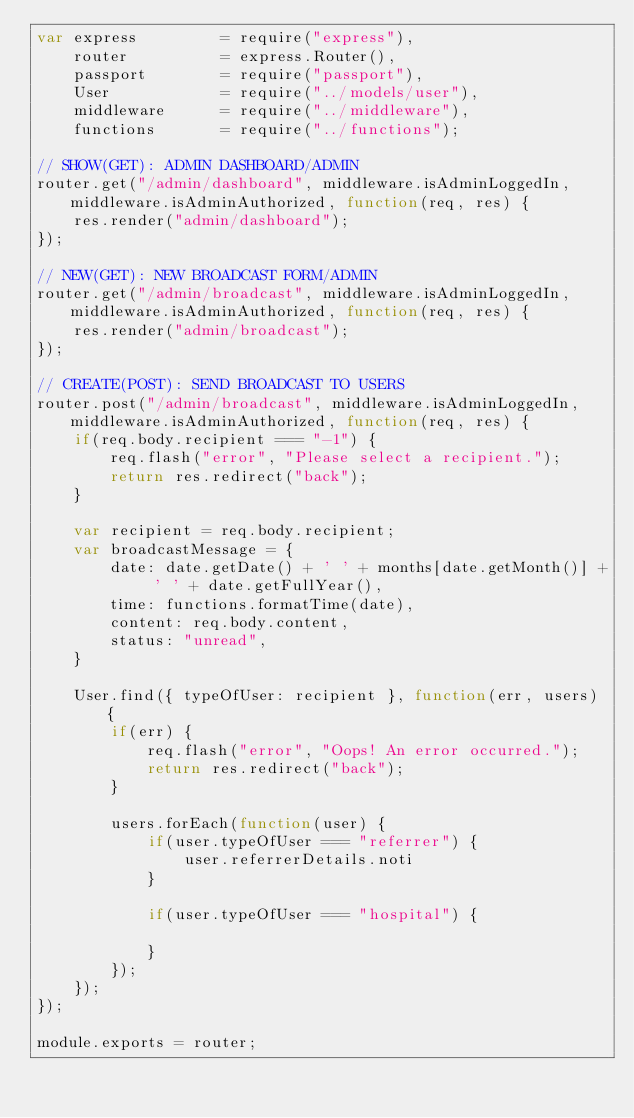Convert code to text. <code><loc_0><loc_0><loc_500><loc_500><_JavaScript_>var express         = require("express"),
    router          = express.Router(),
    passport        = require("passport"),
    User            = require("../models/user"),
    middleware      = require("../middleware"),
    functions       = require("../functions");

// SHOW(GET): ADMIN DASHBOARD/ADMIN
router.get("/admin/dashboard", middleware.isAdminLoggedIn, middleware.isAdminAuthorized, function(req, res) {
    res.render("admin/dashboard");
});

// NEW(GET): NEW BROADCAST FORM/ADMIN
router.get("/admin/broadcast", middleware.isAdminLoggedIn, middleware.isAdminAuthorized, function(req, res) {
    res.render("admin/broadcast");
});

// CREATE(POST): SEND BROADCAST TO USERS
router.post("/admin/broadcast", middleware.isAdminLoggedIn, middleware.isAdminAuthorized, function(req, res) {
    if(req.body.recipient === "-1") {
        req.flash("error", "Please select a recipient.");
        return res.redirect("back");
    }
    
    var recipient = req.body.recipient;
    var broadcastMessage = {
        date: date.getDate() + ' ' + months[date.getMonth()] + ' ' + date.getFullYear(),
        time: functions.formatTime(date),
        content: req.body.content,
        status: "unread",
    }

    User.find({ typeOfUser: recipient }, function(err, users) {
        if(err) {
            req.flash("error", "Oops! An error occurred.");
            return res.redirect("back");
        }

        users.forEach(function(user) {
            if(user.typeOfUser === "referrer") {
                user.referrerDetails.noti
            }
            
            if(user.typeOfUser === "hospital") {

            }
        });
    });
});

module.exports = router;</code> 